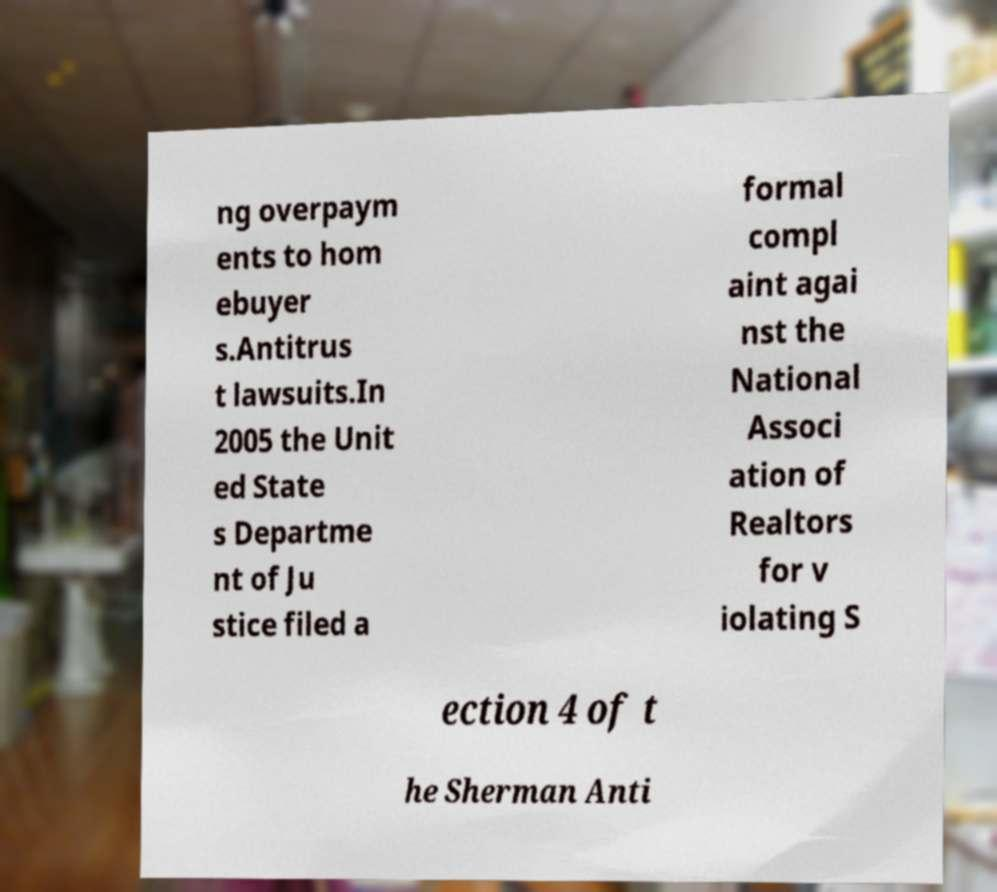There's text embedded in this image that I need extracted. Can you transcribe it verbatim? ng overpaym ents to hom ebuyer s.Antitrus t lawsuits.In 2005 the Unit ed State s Departme nt of Ju stice filed a formal compl aint agai nst the National Associ ation of Realtors for v iolating S ection 4 of t he Sherman Anti 